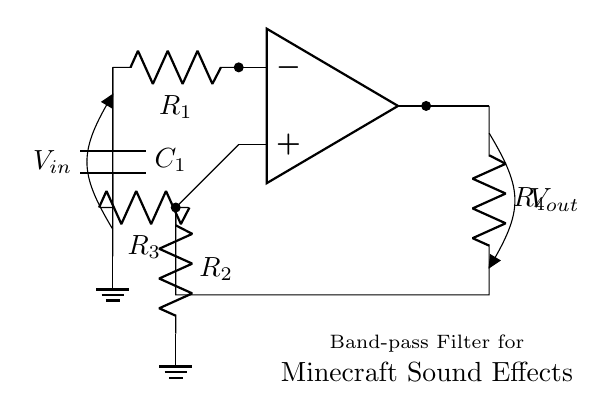What type of filter is this circuit? This circuit is specifically designed as a band-pass filter, which allows a certain range of frequencies to pass through while attenuating frequencies outside of that range.
Answer: Band-pass filter What is the function of the op-amp in this circuit? The op-amp amplifies the input signal, providing gain to the frequencies that fall within the passband of the filter while helping to isolate those frequencies from others.
Answer: Amplification How many resistors are present in this circuit? By counting the resistors labeled R1, R2, R3, and R4, there are a total of four resistors in the circuit.
Answer: Four What is the role of capacitor C1? Capacitor C1 is used to block direct current (DC) while allowing alternating current (AC) signals to pass, contributing to the filtering action of the circuit.
Answer: Blocking DC What components form the voltage input and output? The voltage input is indicated by V_in connected to the input pathway, and V_out is shown at the output node of the circuit, illustrating points for measuring input and output voltages.
Answer: V_in and V_out What does the configuration of R2 and R3 indicate about frequency selection? R2 and R3 are configured to set specific resistance values that define the cutoff frequencies of the band-pass filter, thereby controlling which frequencies are allowed to pass.
Answer: Cutoff frequencies What is the significance of the ground connection in this circuit? The ground connection provides a reference point for voltage levels in the circuit, ensuring stability and serves as a return path for the current, which is critical for the functioning of the op-amp and overall circuit operation.
Answer: Reference point 